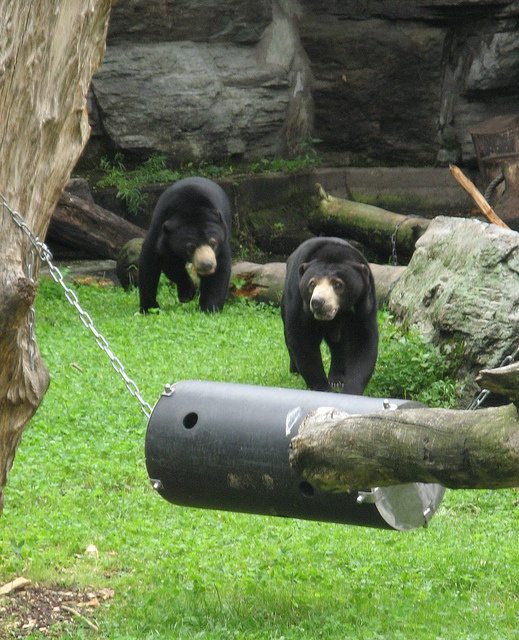Describe the objects in this image and their specific colors. I can see bear in gray, black, and darkgreen tones and bear in gray, black, and darkgreen tones in this image. 